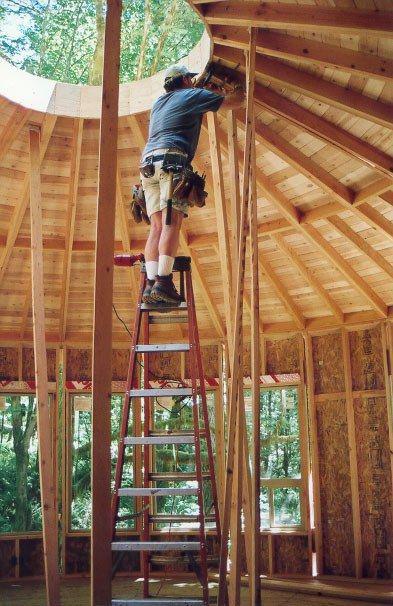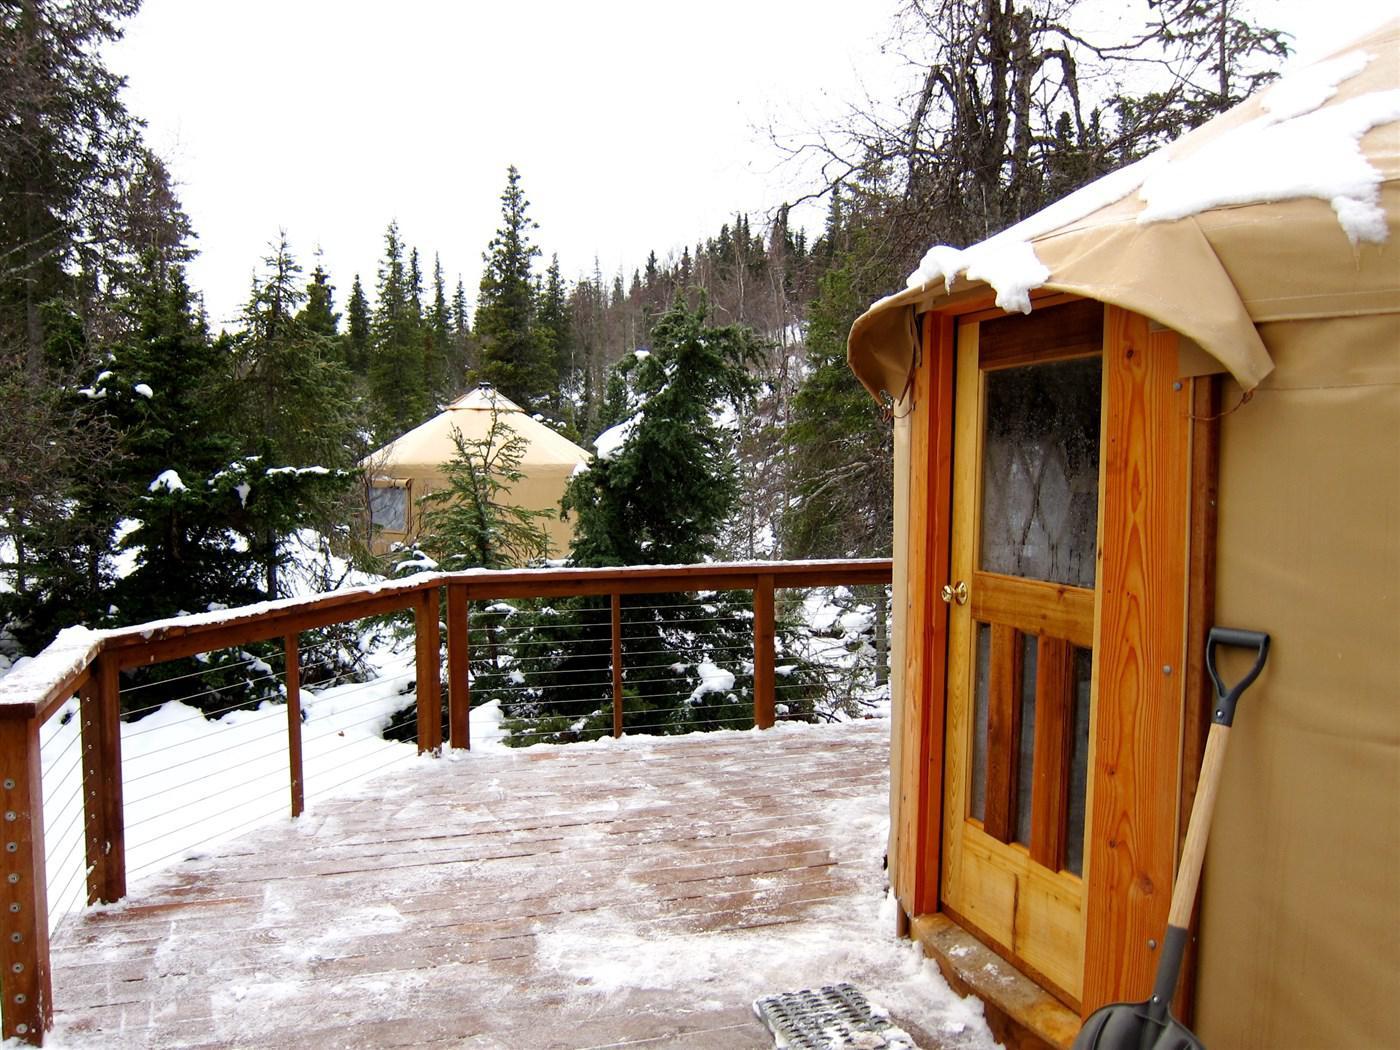The first image is the image on the left, the second image is the image on the right. For the images shown, is this caption "At least one image shows a building in a snowy setting." true? Answer yes or no. Yes. The first image is the image on the left, the second image is the image on the right. For the images shown, is this caption "Both images are interior shots of round houses." true? Answer yes or no. No. 